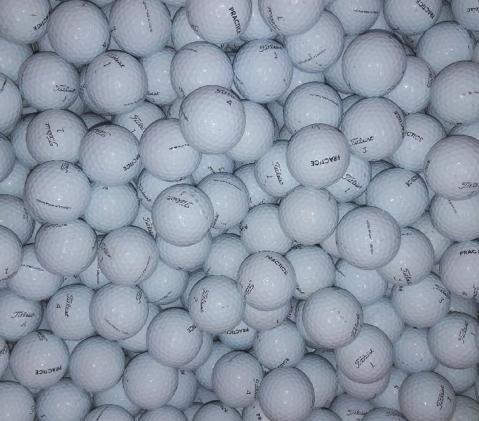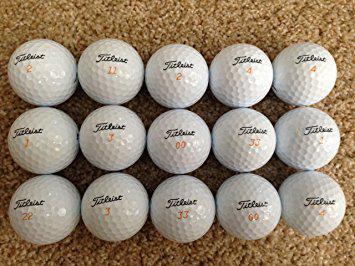The first image is the image on the left, the second image is the image on the right. Evaluate the accuracy of this statement regarding the images: "In at least in image there are at least thirty dirty and muddy golf balls.". Is it true? Answer yes or no. No. The first image is the image on the left, the second image is the image on the right. Given the left and right images, does the statement "One of the images contains nothing but golf balls, the other shows a brown that contains them." hold true? Answer yes or no. Yes. 